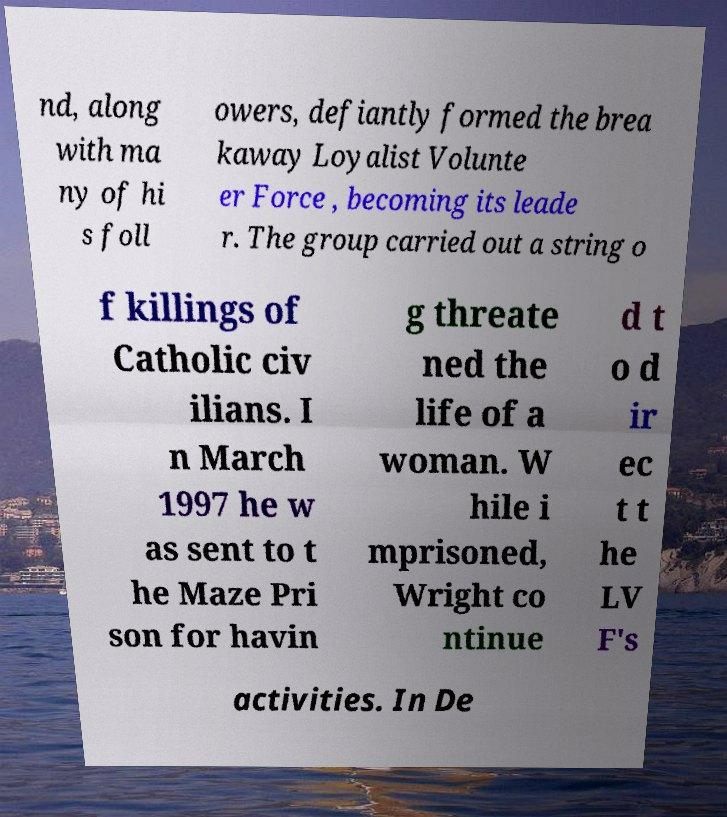Can you read and provide the text displayed in the image?This photo seems to have some interesting text. Can you extract and type it out for me? nd, along with ma ny of hi s foll owers, defiantly formed the brea kaway Loyalist Volunte er Force , becoming its leade r. The group carried out a string o f killings of Catholic civ ilians. I n March 1997 he w as sent to t he Maze Pri son for havin g threate ned the life of a woman. W hile i mprisoned, Wright co ntinue d t o d ir ec t t he LV F's activities. In De 